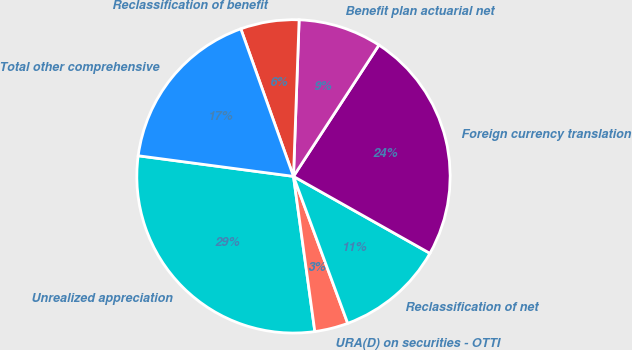Convert chart. <chart><loc_0><loc_0><loc_500><loc_500><pie_chart><fcel>Unrealized appreciation<fcel>URA(D) on securities - OTTI<fcel>Reclassification of net<fcel>Foreign currency translation<fcel>Benefit plan actuarial net<fcel>Reclassification of benefit<fcel>Total other comprehensive<nl><fcel>29.28%<fcel>3.45%<fcel>11.2%<fcel>23.99%<fcel>8.61%<fcel>6.03%<fcel>17.44%<nl></chart> 